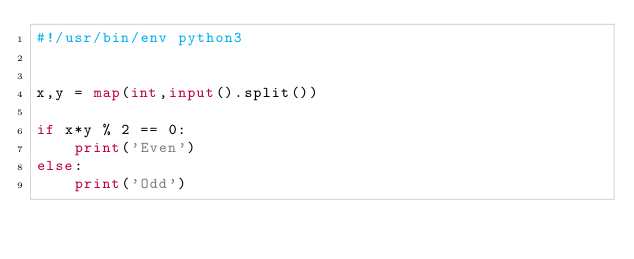<code> <loc_0><loc_0><loc_500><loc_500><_Python_>#!/usr/bin/env python3


x,y = map(int,input().split())

if x*y % 2 == 0:
    print('Even')
else:
    print('Odd')


</code> 